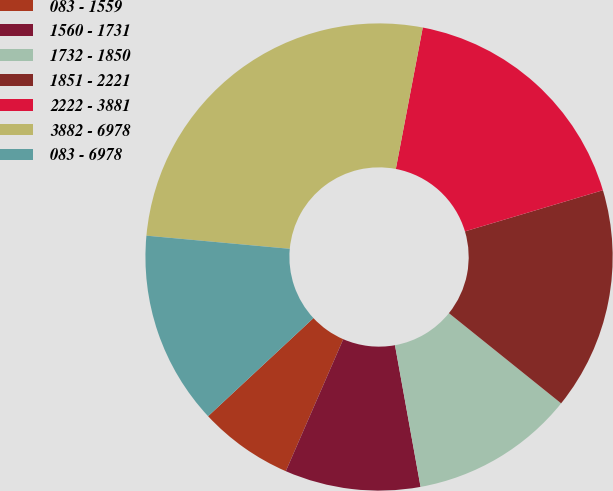Convert chart. <chart><loc_0><loc_0><loc_500><loc_500><pie_chart><fcel>083 - 1559<fcel>1560 - 1731<fcel>1732 - 1850<fcel>1851 - 2221<fcel>2222 - 3881<fcel>3882 - 6978<fcel>083 - 6978<nl><fcel>6.53%<fcel>9.38%<fcel>11.38%<fcel>15.39%<fcel>17.39%<fcel>26.54%<fcel>13.39%<nl></chart> 